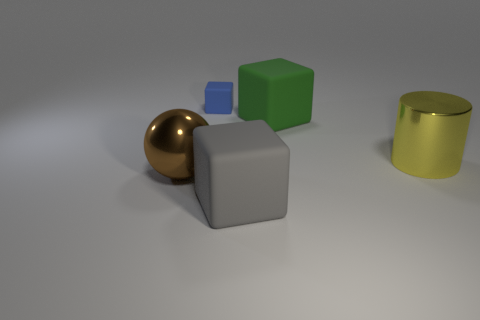Do the big thing in front of the brown shiny ball and the brown sphere have the same material? Based on the image, the big gray item in the foreground does not appear to have the same material as the brown shiny sphere behind it. The former has a matte finish indicative of a solid non-reflective material, possibly concrete or stone, while the latter has a glossy surface that reflects light, suggesting it might be made of polished wood or a coated material to give it that sheen. 